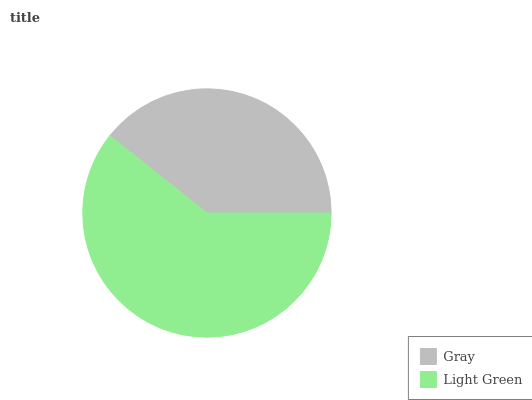Is Gray the minimum?
Answer yes or no. Yes. Is Light Green the maximum?
Answer yes or no. Yes. Is Light Green the minimum?
Answer yes or no. No. Is Light Green greater than Gray?
Answer yes or no. Yes. Is Gray less than Light Green?
Answer yes or no. Yes. Is Gray greater than Light Green?
Answer yes or no. No. Is Light Green less than Gray?
Answer yes or no. No. Is Light Green the high median?
Answer yes or no. Yes. Is Gray the low median?
Answer yes or no. Yes. Is Gray the high median?
Answer yes or no. No. Is Light Green the low median?
Answer yes or no. No. 